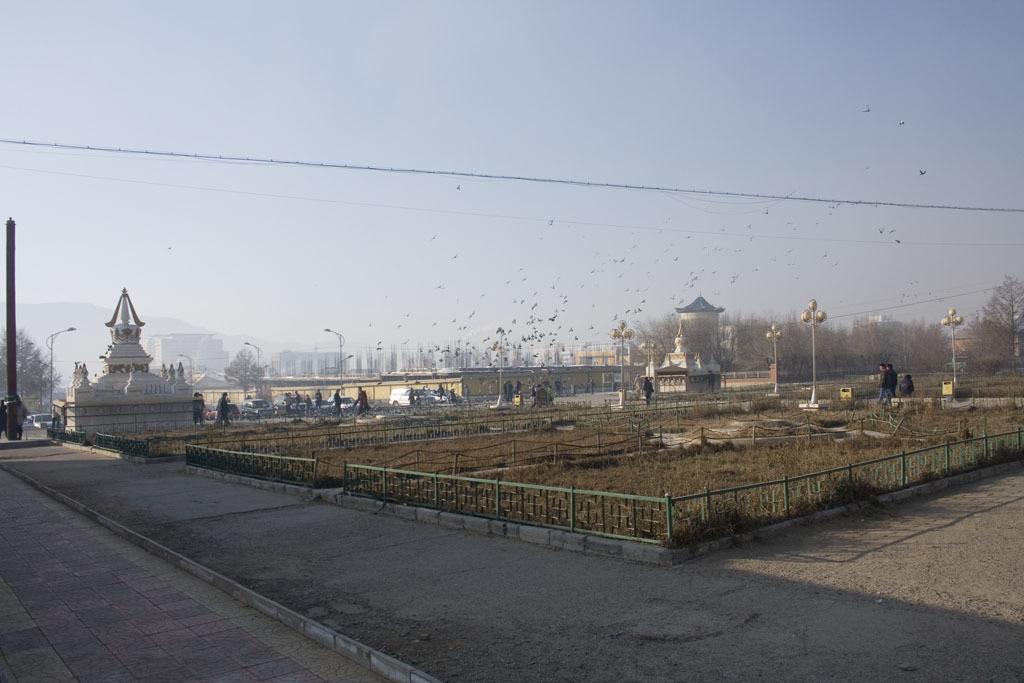Can you describe this image briefly? In this picture we can see grass, some fencing and a few people on the path. We can see street lights, buildings, trees, vehicles and other objects. We can see birds flying in the sky. 